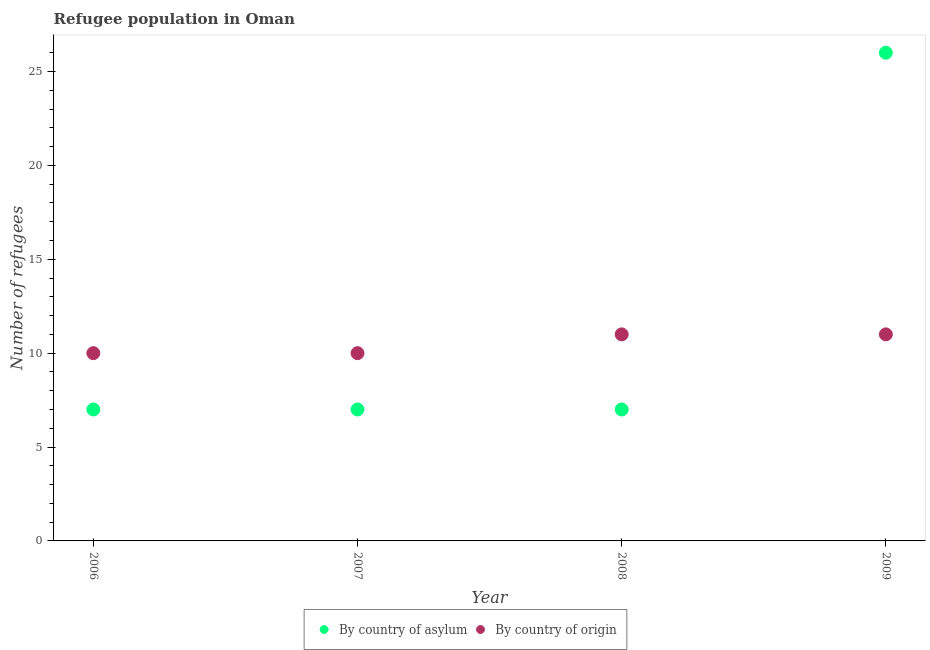Is the number of dotlines equal to the number of legend labels?
Provide a succinct answer. Yes. What is the number of refugees by country of origin in 2009?
Your answer should be very brief. 11. Across all years, what is the maximum number of refugees by country of origin?
Keep it short and to the point. 11. Across all years, what is the minimum number of refugees by country of asylum?
Your answer should be very brief. 7. In which year was the number of refugees by country of origin maximum?
Your answer should be very brief. 2008. In which year was the number of refugees by country of asylum minimum?
Offer a terse response. 2006. What is the total number of refugees by country of asylum in the graph?
Provide a short and direct response. 47. What is the difference between the number of refugees by country of origin in 2007 and that in 2009?
Ensure brevity in your answer.  -1. What is the difference between the number of refugees by country of asylum in 2009 and the number of refugees by country of origin in 2008?
Keep it short and to the point. 15. What is the average number of refugees by country of origin per year?
Your answer should be very brief. 10.5. In the year 2008, what is the difference between the number of refugees by country of asylum and number of refugees by country of origin?
Keep it short and to the point. -4. In how many years, is the number of refugees by country of origin greater than 24?
Ensure brevity in your answer.  0. What is the difference between the highest and the lowest number of refugees by country of asylum?
Offer a very short reply. 19. In how many years, is the number of refugees by country of origin greater than the average number of refugees by country of origin taken over all years?
Offer a terse response. 2. Is the sum of the number of refugees by country of asylum in 2006 and 2007 greater than the maximum number of refugees by country of origin across all years?
Your response must be concise. Yes. How many dotlines are there?
Make the answer very short. 2. How many years are there in the graph?
Offer a very short reply. 4. Are the values on the major ticks of Y-axis written in scientific E-notation?
Offer a very short reply. No. What is the title of the graph?
Your answer should be very brief. Refugee population in Oman. What is the label or title of the Y-axis?
Make the answer very short. Number of refugees. What is the Number of refugees in By country of origin in 2006?
Your answer should be compact. 10. What is the Number of refugees of By country of origin in 2007?
Offer a terse response. 10. What is the Number of refugees of By country of asylum in 2008?
Your response must be concise. 7. What is the Number of refugees of By country of asylum in 2009?
Give a very brief answer. 26. Across all years, what is the maximum Number of refugees in By country of origin?
Provide a succinct answer. 11. Across all years, what is the minimum Number of refugees in By country of asylum?
Offer a very short reply. 7. Across all years, what is the minimum Number of refugees of By country of origin?
Your answer should be compact. 10. What is the total Number of refugees in By country of asylum in the graph?
Provide a short and direct response. 47. What is the total Number of refugees in By country of origin in the graph?
Provide a short and direct response. 42. What is the difference between the Number of refugees in By country of asylum in 2006 and that in 2007?
Keep it short and to the point. 0. What is the difference between the Number of refugees in By country of origin in 2006 and that in 2007?
Keep it short and to the point. 0. What is the difference between the Number of refugees in By country of asylum in 2006 and that in 2008?
Give a very brief answer. 0. What is the difference between the Number of refugees of By country of origin in 2006 and that in 2008?
Give a very brief answer. -1. What is the difference between the Number of refugees of By country of origin in 2006 and that in 2009?
Provide a short and direct response. -1. What is the difference between the Number of refugees of By country of asylum in 2007 and that in 2009?
Your answer should be very brief. -19. What is the difference between the Number of refugees in By country of origin in 2007 and that in 2009?
Your answer should be compact. -1. What is the difference between the Number of refugees of By country of asylum in 2008 and that in 2009?
Offer a very short reply. -19. What is the difference between the Number of refugees in By country of asylum in 2006 and the Number of refugees in By country of origin in 2008?
Your answer should be very brief. -4. What is the difference between the Number of refugees of By country of asylum in 2007 and the Number of refugees of By country of origin in 2008?
Give a very brief answer. -4. What is the difference between the Number of refugees in By country of asylum in 2007 and the Number of refugees in By country of origin in 2009?
Ensure brevity in your answer.  -4. What is the difference between the Number of refugees in By country of asylum in 2008 and the Number of refugees in By country of origin in 2009?
Your response must be concise. -4. What is the average Number of refugees in By country of asylum per year?
Provide a short and direct response. 11.75. In the year 2006, what is the difference between the Number of refugees of By country of asylum and Number of refugees of By country of origin?
Ensure brevity in your answer.  -3. What is the ratio of the Number of refugees in By country of origin in 2006 to that in 2008?
Your response must be concise. 0.91. What is the ratio of the Number of refugees in By country of asylum in 2006 to that in 2009?
Offer a terse response. 0.27. What is the ratio of the Number of refugees of By country of asylum in 2007 to that in 2009?
Keep it short and to the point. 0.27. What is the ratio of the Number of refugees in By country of origin in 2007 to that in 2009?
Ensure brevity in your answer.  0.91. What is the ratio of the Number of refugees in By country of asylum in 2008 to that in 2009?
Ensure brevity in your answer.  0.27. What is the difference between the highest and the second highest Number of refugees of By country of asylum?
Your response must be concise. 19. 